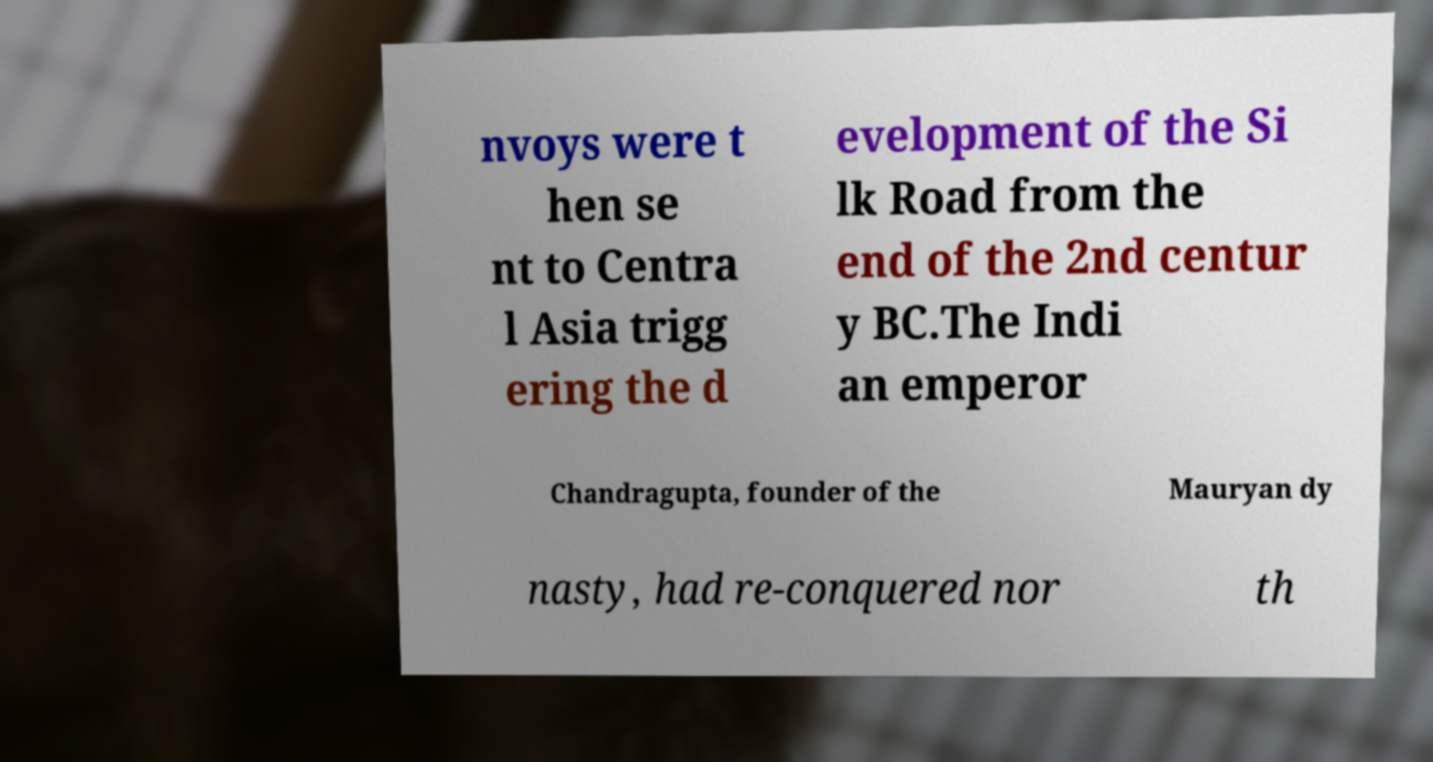Could you assist in decoding the text presented in this image and type it out clearly? nvoys were t hen se nt to Centra l Asia trigg ering the d evelopment of the Si lk Road from the end of the 2nd centur y BC.The Indi an emperor Chandragupta, founder of the Mauryan dy nasty, had re-conquered nor th 